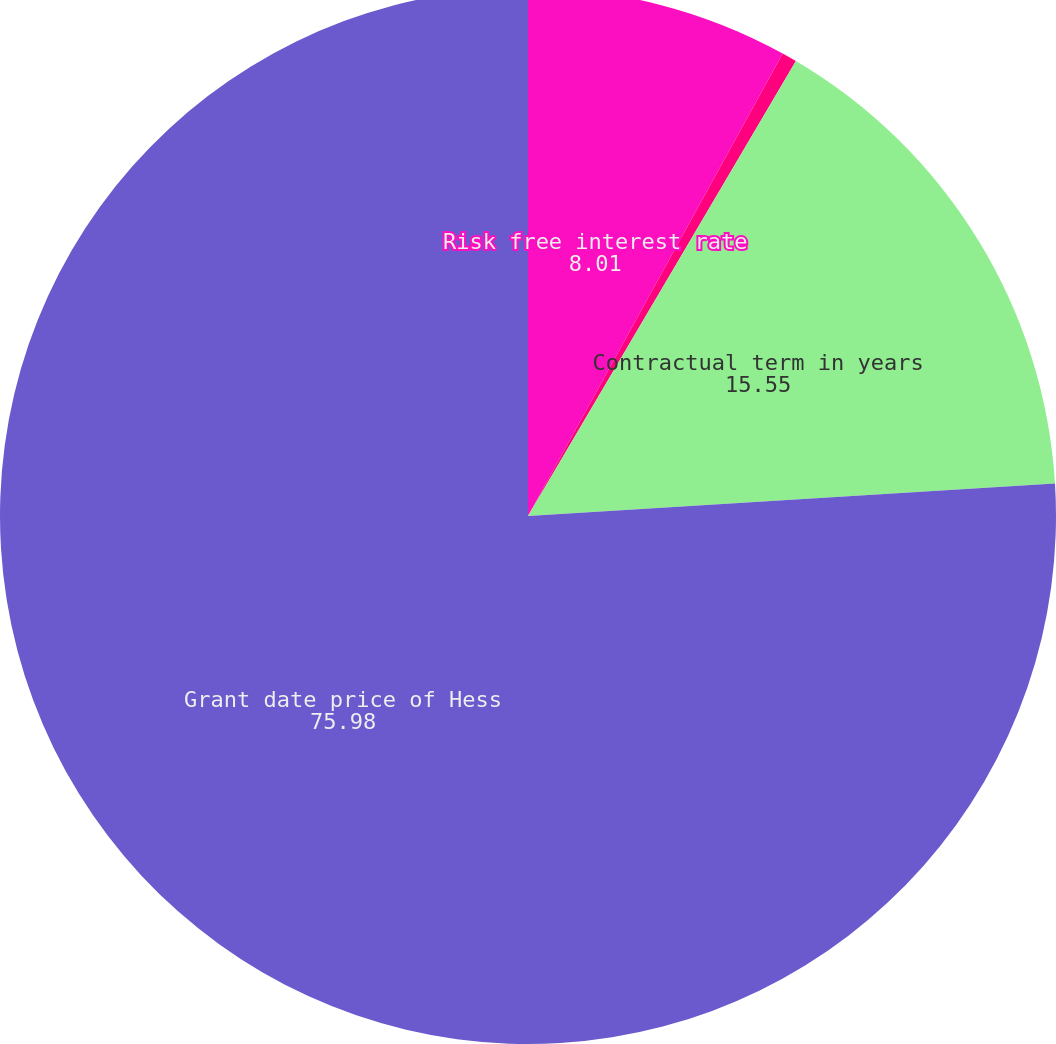<chart> <loc_0><loc_0><loc_500><loc_500><pie_chart><fcel>Risk free interest rate<fcel>Stock price volatility<fcel>Contractual term in years<fcel>Grant date price of Hess<nl><fcel>8.01%<fcel>0.46%<fcel>15.55%<fcel>75.98%<nl></chart> 